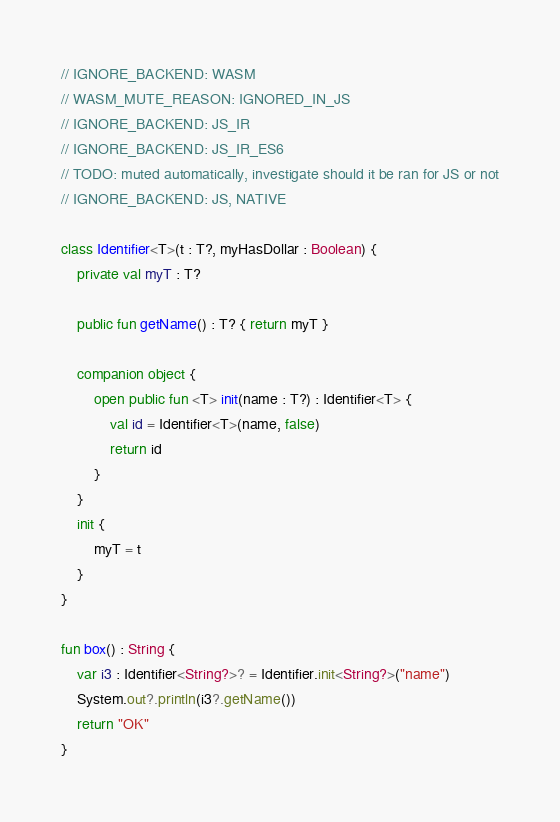<code> <loc_0><loc_0><loc_500><loc_500><_Kotlin_>// IGNORE_BACKEND: WASM
// WASM_MUTE_REASON: IGNORED_IN_JS
// IGNORE_BACKEND: JS_IR
// IGNORE_BACKEND: JS_IR_ES6
// TODO: muted automatically, investigate should it be ran for JS or not
// IGNORE_BACKEND: JS, NATIVE

class Identifier<T>(t : T?, myHasDollar : Boolean) {
    private val myT : T?

    public fun getName() : T? { return myT }

    companion object {
        open public fun <T> init(name : T?) : Identifier<T> {
            val id = Identifier<T>(name, false)
            return id
        }
    }
    init {
        myT = t
    }
}

fun box() : String {
    var i3 : Identifier<String?>? = Identifier.init<String?>("name")
    System.out?.println(i3?.getName())
    return "OK"
}
</code> 